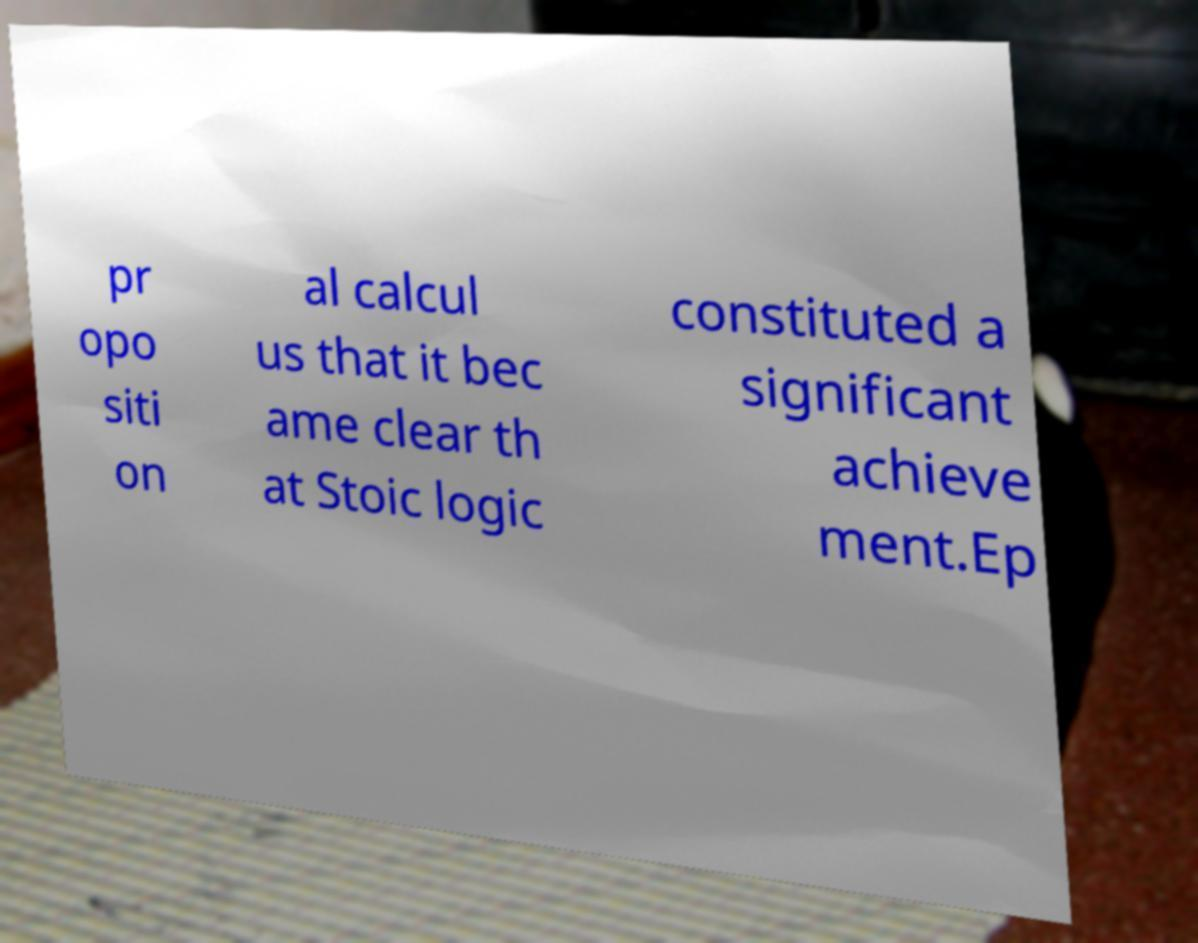Can you read and provide the text displayed in the image?This photo seems to have some interesting text. Can you extract and type it out for me? pr opo siti on al calcul us that it bec ame clear th at Stoic logic constituted a significant achieve ment.Ep 